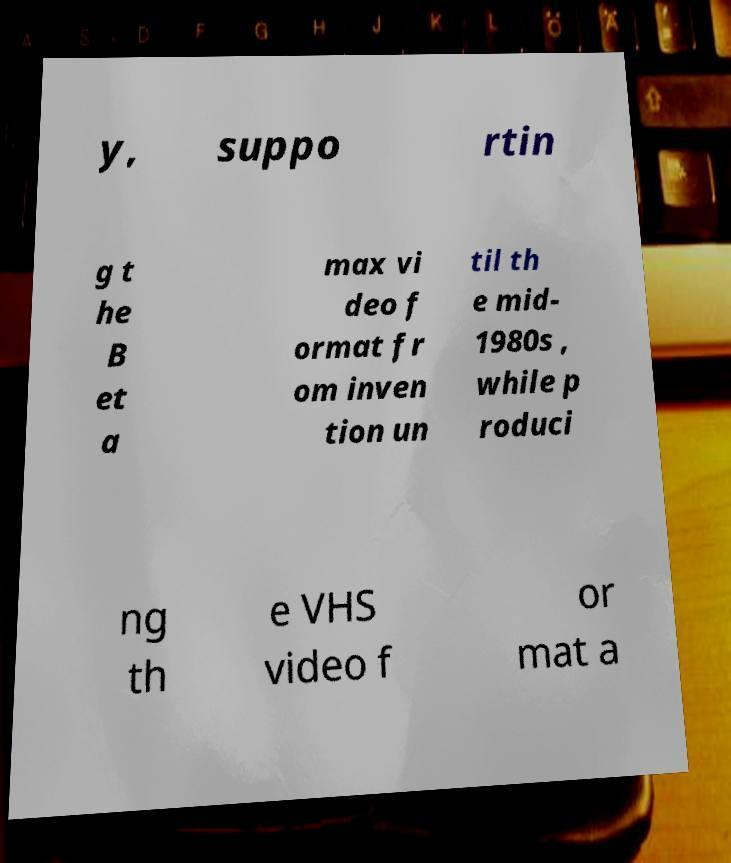Please identify and transcribe the text found in this image. y, suppo rtin g t he B et a max vi deo f ormat fr om inven tion un til th e mid- 1980s , while p roduci ng th e VHS video f or mat a 